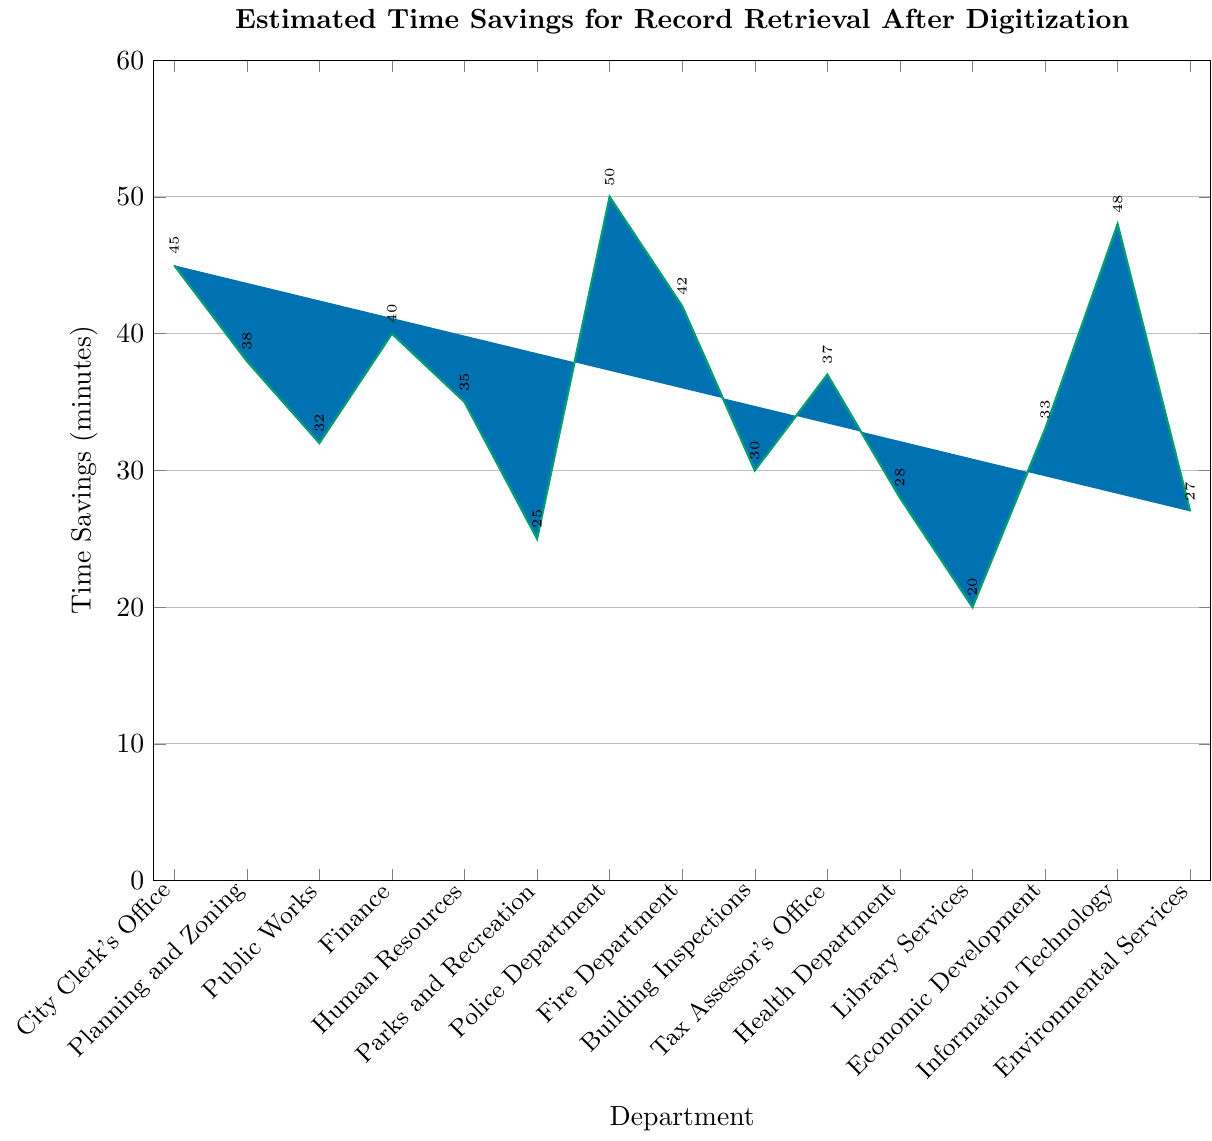what is the department with the highest time savings? The department with the highest time savings is represented by the tallest bar in the figure. The tallness indicates the value of time savings in minutes. Identify the tallest bar which is labeled as the Police Department.
Answer: Police Department which department has the least time savings? The department with the least time savings is represented by the shortest bar in the figure. Identify the shortest bar which is labeled as Library Services.
Answer: Library Services what is the total time savings for the City Clerk's Office, Planning and Zoning, and Public Works? Sum the time savings of City Clerk's Office (45 minutes), Planning and Zoning (38 minutes), and Public Works (32 minutes). The calculation is 45 + 38 + 32 = 115 minutes.
Answer: 115 minutes which departments have time savings greater than 40 minutes? Identify the bars that represent departments with time savings greater than 40 minutes. These are the City Clerk's Office (45), Finance (40), Police Department (50), Fire Department (42), and Information Technology (48).
Answer: City Clerk's Office, Police Department, Fire Department, Information Technology how much more time savings does the Police Department have compared to Library Services? Subtract the time savings of Library Services (20 minutes) from the time savings of the Police Department (50 minutes). The calculation is 50 - 20 = 30 minutes.
Answer: 30 minutes what is the average time savings across all departments? Sum the time savings for all departments and then divide by the number of departments. The sum is 45 + 38 + 32 + 40 + 35 + 25 + 50 + 42 + 30 + 37 + 28 + 20 + 33 + 48 + 27 = 530 minutes. There are 15 departments. The average is 530 / 15 = 35.33 minutes.
Answer: 35.33 minutes which two departments have the same time savings? Compare the bars to identify any two departments with the same time savings value. Both Finance and Human Resources have the same time savings of 40 minutes.
Answer: Finance and Human Resources is the time savings for Finance greater than that for Public Works? Compare the height of the bars for Finance and Public Works. Finance has a time savings of 40 minutes, whereas Public Works has 32 minutes. Since 40 is greater than 32, Finance has greater time savings.
Answer: Yes what is the difference in time savings between Economic Development and Environmental Services? Subtract the time savings of Environmental Services (27 minutes) from the time savings of Economic Development (33 minutes). The calculation is 33 - 27 = 6 minutes.
Answer: 6 minutes which department has a time savings exactly in between the highest and the lowest? The highest time savings is 50 minutes (Police Department), and the lowest is 20 minutes (Library Services). The midway point is (50 + 20) / 2 = 35 minutes. Compare this with the department values and identify Human Resources, which has exactly 35 minutes.
Answer: Human Resources 